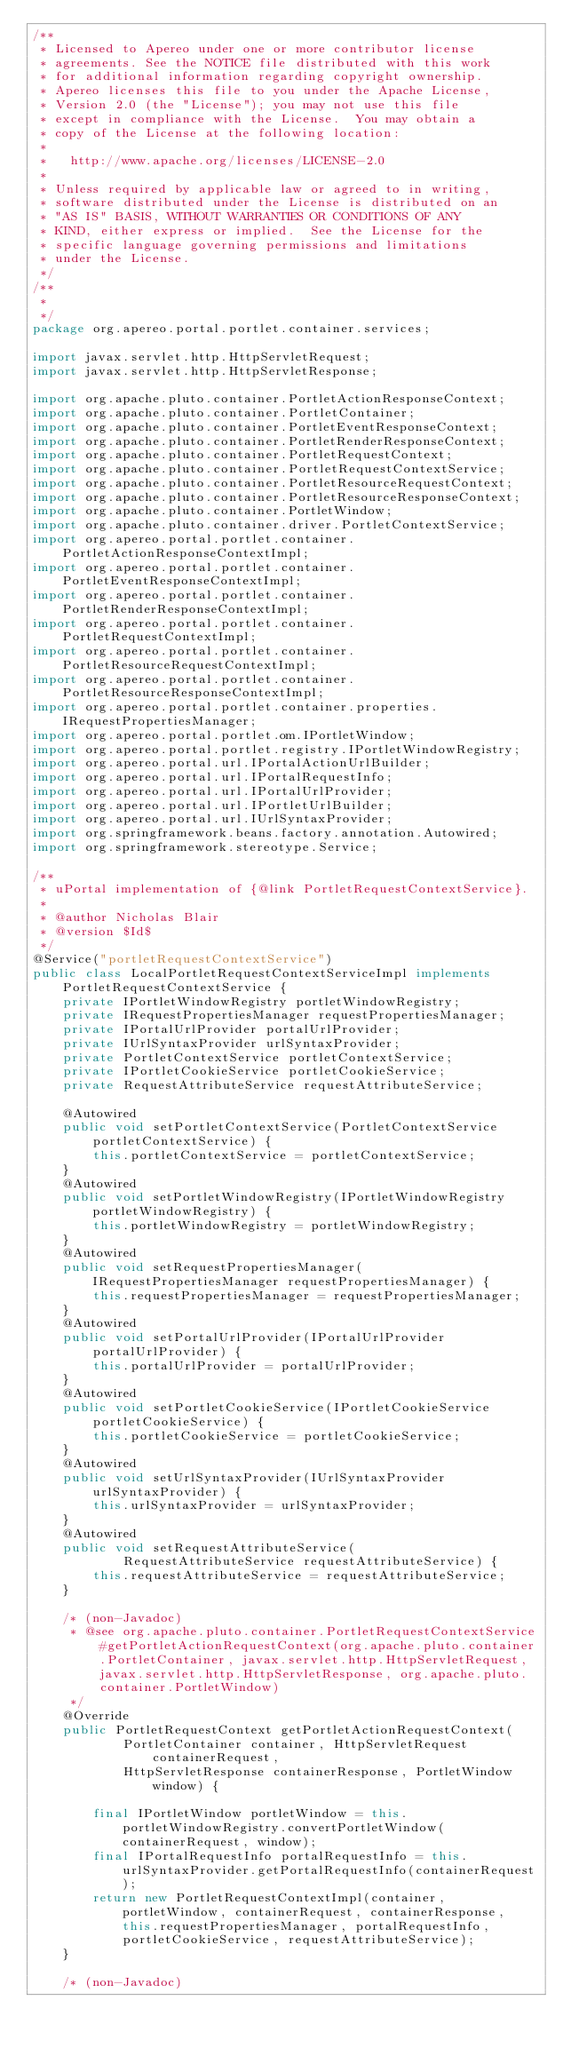<code> <loc_0><loc_0><loc_500><loc_500><_Java_>/**
 * Licensed to Apereo under one or more contributor license
 * agreements. See the NOTICE file distributed with this work
 * for additional information regarding copyright ownership.
 * Apereo licenses this file to you under the Apache License,
 * Version 2.0 (the "License"); you may not use this file
 * except in compliance with the License.  You may obtain a
 * copy of the License at the following location:
 *
 *   http://www.apache.org/licenses/LICENSE-2.0
 *
 * Unless required by applicable law or agreed to in writing,
 * software distributed under the License is distributed on an
 * "AS IS" BASIS, WITHOUT WARRANTIES OR CONDITIONS OF ANY
 * KIND, either express or implied.  See the License for the
 * specific language governing permissions and limitations
 * under the License.
 */
/**
 * 
 */
package org.apereo.portal.portlet.container.services;

import javax.servlet.http.HttpServletRequest;
import javax.servlet.http.HttpServletResponse;

import org.apache.pluto.container.PortletActionResponseContext;
import org.apache.pluto.container.PortletContainer;
import org.apache.pluto.container.PortletEventResponseContext;
import org.apache.pluto.container.PortletRenderResponseContext;
import org.apache.pluto.container.PortletRequestContext;
import org.apache.pluto.container.PortletRequestContextService;
import org.apache.pluto.container.PortletResourceRequestContext;
import org.apache.pluto.container.PortletResourceResponseContext;
import org.apache.pluto.container.PortletWindow;
import org.apache.pluto.container.driver.PortletContextService;
import org.apereo.portal.portlet.container.PortletActionResponseContextImpl;
import org.apereo.portal.portlet.container.PortletEventResponseContextImpl;
import org.apereo.portal.portlet.container.PortletRenderResponseContextImpl;
import org.apereo.portal.portlet.container.PortletRequestContextImpl;
import org.apereo.portal.portlet.container.PortletResourceRequestContextImpl;
import org.apereo.portal.portlet.container.PortletResourceResponseContextImpl;
import org.apereo.portal.portlet.container.properties.IRequestPropertiesManager;
import org.apereo.portal.portlet.om.IPortletWindow;
import org.apereo.portal.portlet.registry.IPortletWindowRegistry;
import org.apereo.portal.url.IPortalActionUrlBuilder;
import org.apereo.portal.url.IPortalRequestInfo;
import org.apereo.portal.url.IPortalUrlProvider;
import org.apereo.portal.url.IPortletUrlBuilder;
import org.apereo.portal.url.IUrlSyntaxProvider;
import org.springframework.beans.factory.annotation.Autowired;
import org.springframework.stereotype.Service;

/**
 * uPortal implementation of {@link PortletRequestContextService}.
 * 
 * @author Nicholas Blair
 * @version $Id$
 */
@Service("portletRequestContextService")
public class LocalPortletRequestContextServiceImpl implements PortletRequestContextService {
    private IPortletWindowRegistry portletWindowRegistry;
    private IRequestPropertiesManager requestPropertiesManager;
    private IPortalUrlProvider portalUrlProvider;
    private IUrlSyntaxProvider urlSyntaxProvider;
    private PortletContextService portletContextService;
    private IPortletCookieService portletCookieService;
    private RequestAttributeService requestAttributeService;

    @Autowired
    public void setPortletContextService(PortletContextService portletContextService) {
        this.portletContextService = portletContextService;
    }
    @Autowired
	public void setPortletWindowRegistry(IPortletWindowRegistry portletWindowRegistry) {
        this.portletWindowRegistry = portletWindowRegistry;
    }
    @Autowired
    public void setRequestPropertiesManager(IRequestPropertiesManager requestPropertiesManager) {
        this.requestPropertiesManager = requestPropertiesManager;
    }
    @Autowired
    public void setPortalUrlProvider(IPortalUrlProvider portalUrlProvider) {
        this.portalUrlProvider = portalUrlProvider;
    }
    @Autowired
    public void setPortletCookieService(IPortletCookieService portletCookieService) {
        this.portletCookieService = portletCookieService;
    }  
    @Autowired
    public void setUrlSyntaxProvider(IUrlSyntaxProvider urlSyntaxProvider) {
        this.urlSyntaxProvider = urlSyntaxProvider;
    }
    @Autowired
	public void setRequestAttributeService(
			RequestAttributeService requestAttributeService) {
		this.requestAttributeService = requestAttributeService;
	}

	/* (non-Javadoc)
	 * @see org.apache.pluto.container.PortletRequestContextService#getPortletActionRequestContext(org.apache.pluto.container.PortletContainer, javax.servlet.http.HttpServletRequest, javax.servlet.http.HttpServletResponse, org.apache.pluto.container.PortletWindow)
	 */
	@Override
	public PortletRequestContext getPortletActionRequestContext(
			PortletContainer container, HttpServletRequest containerRequest,
			HttpServletResponse containerResponse, PortletWindow window) {
	    
	    final IPortletWindow portletWindow = this.portletWindowRegistry.convertPortletWindow(containerRequest, window);
	    final IPortalRequestInfo portalRequestInfo = this.urlSyntaxProvider.getPortalRequestInfo(containerRequest);
	    return new PortletRequestContextImpl(container, portletWindow, containerRequest, containerResponse, this.requestPropertiesManager, portalRequestInfo, portletCookieService, requestAttributeService);
	}

	/* (non-Javadoc)</code> 